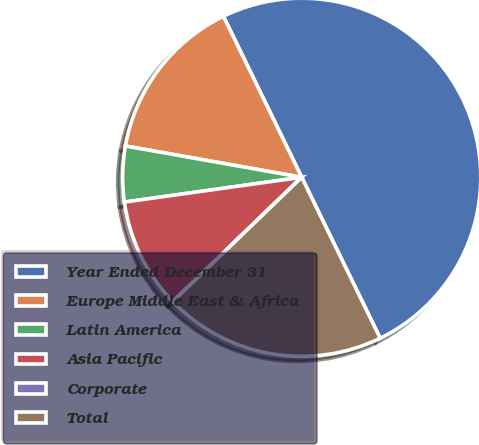Convert chart. <chart><loc_0><loc_0><loc_500><loc_500><pie_chart><fcel>Year Ended December 31<fcel>Europe Middle East & Africa<fcel>Latin America<fcel>Asia Pacific<fcel>Corporate<fcel>Total<nl><fcel>49.99%<fcel>15.0%<fcel>5.01%<fcel>10.0%<fcel>0.01%<fcel>20.0%<nl></chart> 